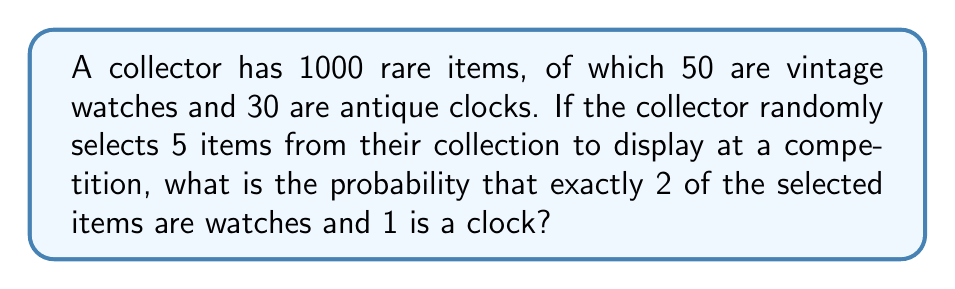Could you help me with this problem? Let's approach this step-by-step using the concept of hypergeometric distribution:

1) First, we need to calculate the number of ways to select:
   - 2 watches out of 50
   - 1 clock out of 30
   - 2 other items out of the remaining 920 (1000 - 50 - 30)

2) We can use the combination formula for each:
   - Watches: $\binom{50}{2}$
   - Clocks: $\binom{30}{1}$
   - Other items: $\binom{920}{2}$

3) The total number of favorable outcomes is the product of these:

   $$\binom{50}{2} \cdot \binom{30}{1} \cdot \binom{920}{2}$$

4) The total number of ways to select 5 items from 1000 is:

   $$\binom{1000}{5}$$

5) The probability is the number of favorable outcomes divided by the total number of possible outcomes:

   $$P = \frac{\binom{50}{2} \cdot \binom{30}{1} \cdot \binom{920}{2}}{\binom{1000}{5}}$$

6) Let's calculate each part:
   - $\binom{50}{2} = 1225$
   - $\binom{30}{1} = 30$
   - $\binom{920}{2} = 422,860$
   - $\binom{1000}{5} = 8,250,296,000$

7) Substituting these values:

   $$P = \frac{1225 \cdot 30 \cdot 422,860}{8,250,296,000} \approx 0.001872$$
Answer: $\frac{15,541,605,000}{8,250,296,000} \approx 0.001872$ 